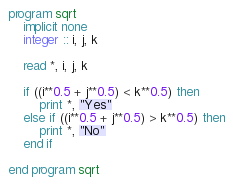<code> <loc_0><loc_0><loc_500><loc_500><_FORTRAN_>program sqrt
    implicit none
    integer :: i, j, k

    read *, i, j, k

    if ((i**0.5 + j**0.5) < k**0.5) then
        print *, "Yes"
    else if ((i**0.5 + j**0.5) > k**0.5) then
        print *, "No"
    end if

end program sqrt
</code> 